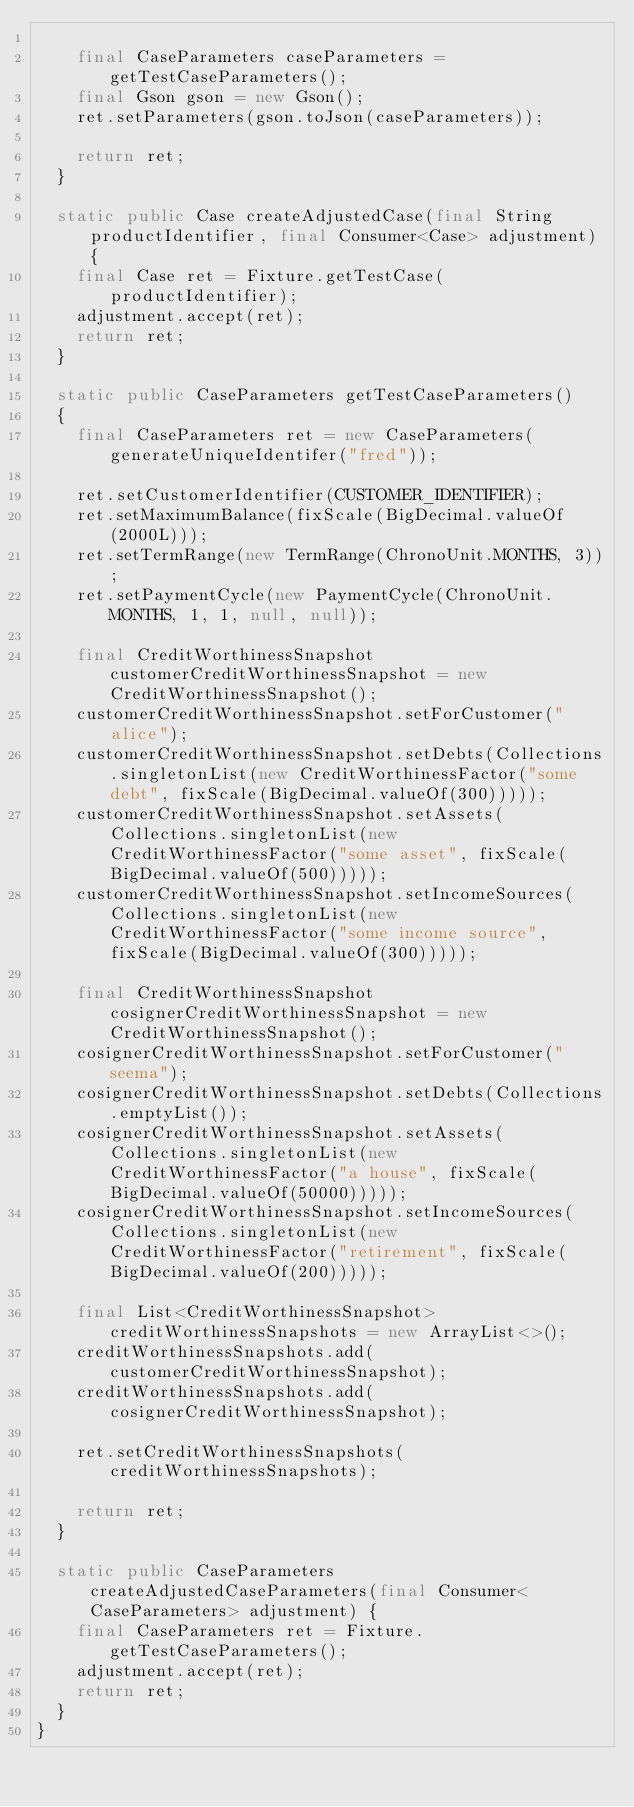Convert code to text. <code><loc_0><loc_0><loc_500><loc_500><_Java_>
    final CaseParameters caseParameters = getTestCaseParameters();
    final Gson gson = new Gson();
    ret.setParameters(gson.toJson(caseParameters));

    return ret;
  }

  static public Case createAdjustedCase(final String productIdentifier, final Consumer<Case> adjustment) {
    final Case ret = Fixture.getTestCase(productIdentifier);
    adjustment.accept(ret);
    return ret;
  }

  static public CaseParameters getTestCaseParameters()
  {
    final CaseParameters ret = new CaseParameters(generateUniqueIdentifer("fred"));

    ret.setCustomerIdentifier(CUSTOMER_IDENTIFIER);
    ret.setMaximumBalance(fixScale(BigDecimal.valueOf(2000L)));
    ret.setTermRange(new TermRange(ChronoUnit.MONTHS, 3));
    ret.setPaymentCycle(new PaymentCycle(ChronoUnit.MONTHS, 1, 1, null, null));

    final CreditWorthinessSnapshot customerCreditWorthinessSnapshot = new CreditWorthinessSnapshot();
    customerCreditWorthinessSnapshot.setForCustomer("alice");
    customerCreditWorthinessSnapshot.setDebts(Collections.singletonList(new CreditWorthinessFactor("some debt", fixScale(BigDecimal.valueOf(300)))));
    customerCreditWorthinessSnapshot.setAssets(Collections.singletonList(new CreditWorthinessFactor("some asset", fixScale(BigDecimal.valueOf(500)))));
    customerCreditWorthinessSnapshot.setIncomeSources(Collections.singletonList(new CreditWorthinessFactor("some income source", fixScale(BigDecimal.valueOf(300)))));

    final CreditWorthinessSnapshot cosignerCreditWorthinessSnapshot = new CreditWorthinessSnapshot();
    cosignerCreditWorthinessSnapshot.setForCustomer("seema");
    cosignerCreditWorthinessSnapshot.setDebts(Collections.emptyList());
    cosignerCreditWorthinessSnapshot.setAssets(Collections.singletonList(new CreditWorthinessFactor("a house", fixScale(BigDecimal.valueOf(50000)))));
    cosignerCreditWorthinessSnapshot.setIncomeSources(Collections.singletonList(new CreditWorthinessFactor("retirement", fixScale(BigDecimal.valueOf(200)))));

    final List<CreditWorthinessSnapshot> creditWorthinessSnapshots = new ArrayList<>();
    creditWorthinessSnapshots.add(customerCreditWorthinessSnapshot);
    creditWorthinessSnapshots.add(cosignerCreditWorthinessSnapshot);

    ret.setCreditWorthinessSnapshots(creditWorthinessSnapshots);

    return ret;
  }

  static public CaseParameters createAdjustedCaseParameters(final Consumer<CaseParameters> adjustment) {
    final CaseParameters ret = Fixture.getTestCaseParameters();
    adjustment.accept(ret);
    return ret;
  }
}</code> 